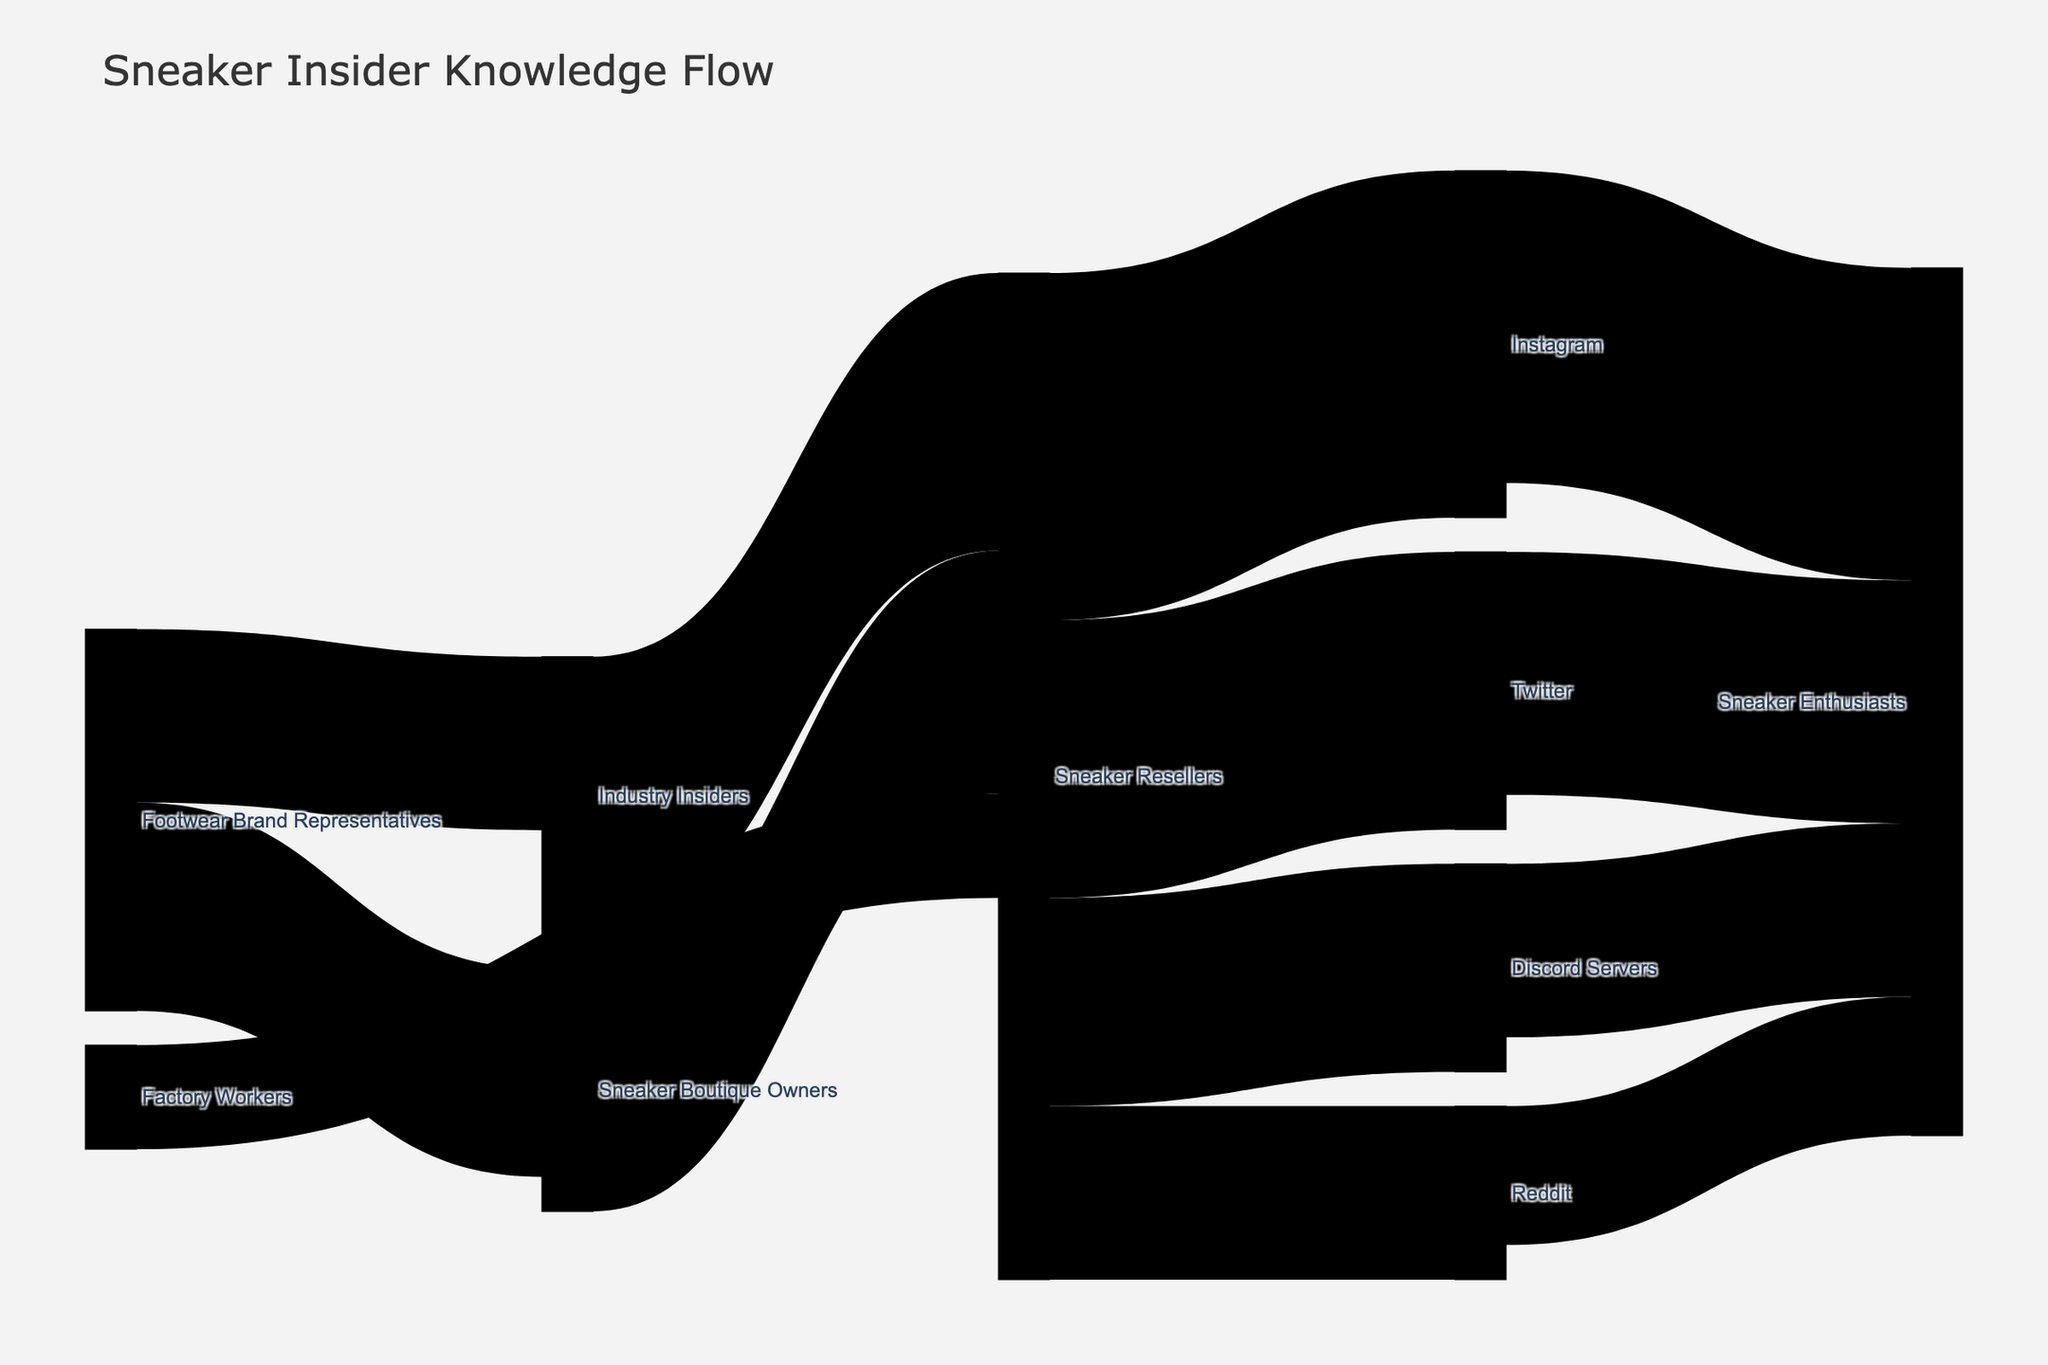What is the title of the Sankey diagram? The title of the Sankey diagram is prominently displayed at the top of the figure. By looking at the title, we can directly see what the diagram is about.
Answer: Sneaker Insider Knowledge Flow Which source provides the most information to Sneaker Resellers? To answer this, look at all the sources connected to Sneaker Resellers and compare their values. Add up values from Industry Insiders, Boutique Owners, and Factory Workers to identify the largest contribution. Industry Insiders contribute 40, Sneaker Boutique Owners contribute 35, and Factory Workers contribute 15. 40 is the largest value.
Answer: Industry Insiders What is the total amount of information flowing from Sneaker Resellers to social media platforms? Identify all the values connecting Sneaker Resellers to social media (Instagram, Twitter, Reddit, Discord Servers) and sum them up. The values are 50 (Instagram) + 40 (Twitter) + 25 (Reddit) + 30 (Discord Servers). Therefore, 50 + 40 + 25 + 30 = 145.
Answer: 145 Is there more information flowing to Instagram or Discord Servers from Sneaker Resellers? To answer this, compare the two Sankey link values going from Sneaker Resellers to Instagram and Discord Servers. Instagram receives 50 whilst Discord Servers receive 30.
Answer: Instagram How many target groups does Instagram pass information to? Look at how many outgoing connections originate from Instagram. Count the number of unique targets connected directly to Instagram. In the diagram, Instagram passes information to Sneaker Enthusiasts.
Answer: 1 Who receives more information from Sneaker Resellers, Twitter or Reddit? Compare the values associated with the links connecting Sneaker Resellers to Twitter and Reddit. Twitter receives 40, while Reddit receives 25.
Answer: Twitter What is the combined value of information flowing from Footwear Brand Representatives? Summarize the values of all outgoing links from Footwear Brand Representatives. They are 30 (to Sneaker Boutique Owners) and 25 (to Industry Insiders). Thus, 30 + 25 = 55.
Answer: 55 Which two roles contribute information to Industry Insiders? Identify the sources connected to Industry Insiders and list them. Footwear Brand Representatives contribute 25 and no other roles are listed as sources for Industry Insiders.
Answer: Footwear Brand Representatives To which social media platform do Sneaker Resellers share the most information? Compare the values of the links connecting Sneaker Resellers to each social media platform and find the largest. Instagram receives the most with a value of 50.
Answer: Instagram What is the overall flow of information from Footwear Brand Representatives to social media platforms? Trace the paths from Footwear Brand Representatives: 
1. Footwear Brand Representatives to Sneaker Boutique Owners to Sneaker Resellers to social media (30).
2. Footwear Brand Representatives to Industry Insiders to Sneaker Resellers to social media (25).
Summarize the values for each path:
30 + 25 = 55; both leading to Sneaker Resellers who then distribute 145 to social media platforms. So, the total flow is 55.
Answer: 55 